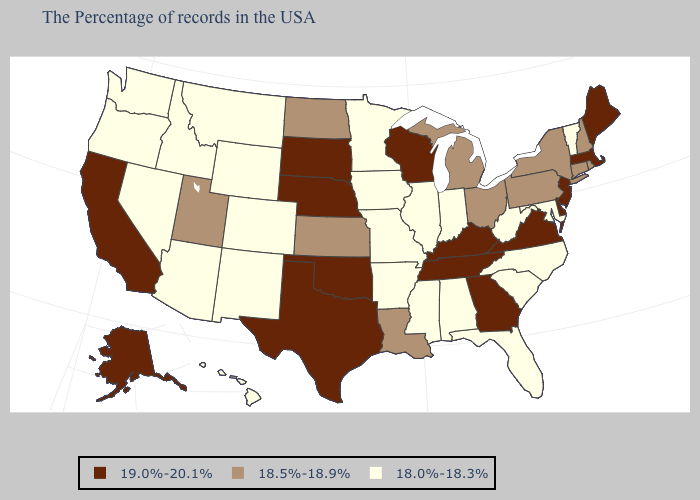Name the states that have a value in the range 18.0%-18.3%?
Concise answer only. Vermont, Maryland, North Carolina, South Carolina, West Virginia, Florida, Indiana, Alabama, Illinois, Mississippi, Missouri, Arkansas, Minnesota, Iowa, Wyoming, Colorado, New Mexico, Montana, Arizona, Idaho, Nevada, Washington, Oregon, Hawaii. Name the states that have a value in the range 18.5%-18.9%?
Answer briefly. Rhode Island, New Hampshire, Connecticut, New York, Pennsylvania, Ohio, Michigan, Louisiana, Kansas, North Dakota, Utah. Does the map have missing data?
Be succinct. No. Is the legend a continuous bar?
Give a very brief answer. No. What is the lowest value in the South?
Write a very short answer. 18.0%-18.3%. Does Michigan have a lower value than Kentucky?
Concise answer only. Yes. Among the states that border Maryland , which have the highest value?
Short answer required. Delaware, Virginia. Name the states that have a value in the range 18.5%-18.9%?
Answer briefly. Rhode Island, New Hampshire, Connecticut, New York, Pennsylvania, Ohio, Michigan, Louisiana, Kansas, North Dakota, Utah. Name the states that have a value in the range 18.5%-18.9%?
Be succinct. Rhode Island, New Hampshire, Connecticut, New York, Pennsylvania, Ohio, Michigan, Louisiana, Kansas, North Dakota, Utah. Among the states that border Florida , which have the lowest value?
Write a very short answer. Alabama. What is the value of North Dakota?
Answer briefly. 18.5%-18.9%. What is the highest value in states that border Texas?
Write a very short answer. 19.0%-20.1%. Among the states that border Virginia , which have the highest value?
Concise answer only. Kentucky, Tennessee. What is the highest value in the MidWest ?
Keep it brief. 19.0%-20.1%. Name the states that have a value in the range 18.5%-18.9%?
Write a very short answer. Rhode Island, New Hampshire, Connecticut, New York, Pennsylvania, Ohio, Michigan, Louisiana, Kansas, North Dakota, Utah. 